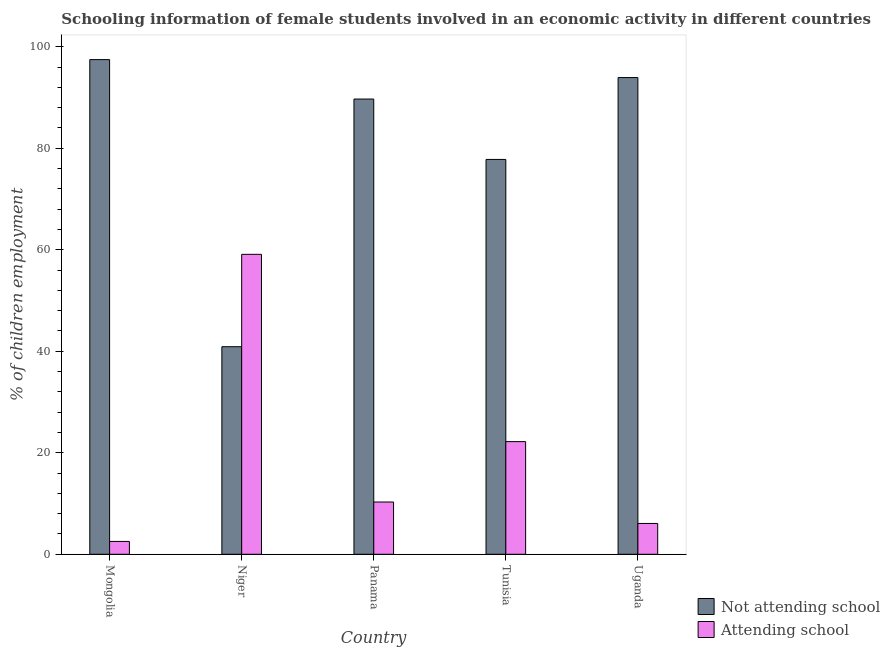How many different coloured bars are there?
Ensure brevity in your answer.  2. How many groups of bars are there?
Ensure brevity in your answer.  5. Are the number of bars per tick equal to the number of legend labels?
Give a very brief answer. Yes. Are the number of bars on each tick of the X-axis equal?
Provide a short and direct response. Yes. How many bars are there on the 5th tick from the right?
Your response must be concise. 2. What is the label of the 2nd group of bars from the left?
Offer a terse response. Niger. In how many cases, is the number of bars for a given country not equal to the number of legend labels?
Give a very brief answer. 0. What is the percentage of employed females who are not attending school in Niger?
Ensure brevity in your answer.  40.9. Across all countries, what is the maximum percentage of employed females who are attending school?
Your answer should be compact. 59.1. Across all countries, what is the minimum percentage of employed females who are attending school?
Keep it short and to the point. 2.53. In which country was the percentage of employed females who are not attending school maximum?
Your answer should be compact. Mongolia. In which country was the percentage of employed females who are not attending school minimum?
Provide a short and direct response. Niger. What is the total percentage of employed females who are attending school in the graph?
Offer a terse response. 100.2. What is the difference between the percentage of employed females who are attending school in Mongolia and that in Uganda?
Give a very brief answer. -3.54. What is the difference between the percentage of employed females who are not attending school in Panama and the percentage of employed females who are attending school in Mongolia?
Offer a terse response. 87.17. What is the average percentage of employed females who are attending school per country?
Your response must be concise. 20.04. What is the difference between the percentage of employed females who are attending school and percentage of employed females who are not attending school in Uganda?
Give a very brief answer. -87.86. In how many countries, is the percentage of employed females who are attending school greater than 56 %?
Provide a succinct answer. 1. What is the ratio of the percentage of employed females who are attending school in Mongolia to that in Panama?
Provide a succinct answer. 0.25. Is the percentage of employed females who are attending school in Mongolia less than that in Uganda?
Ensure brevity in your answer.  Yes. What is the difference between the highest and the second highest percentage of employed females who are not attending school?
Offer a very short reply. 3.54. What is the difference between the highest and the lowest percentage of employed females who are attending school?
Your answer should be compact. 56.57. What does the 2nd bar from the left in Mongolia represents?
Provide a succinct answer. Attending school. What does the 2nd bar from the right in Uganda represents?
Provide a succinct answer. Not attending school. How many bars are there?
Provide a succinct answer. 10. Are the values on the major ticks of Y-axis written in scientific E-notation?
Provide a short and direct response. No. How many legend labels are there?
Make the answer very short. 2. What is the title of the graph?
Keep it short and to the point. Schooling information of female students involved in an economic activity in different countries. Does "Primary completion rate" appear as one of the legend labels in the graph?
Provide a succinct answer. No. What is the label or title of the X-axis?
Offer a terse response. Country. What is the label or title of the Y-axis?
Provide a succinct answer. % of children employment. What is the % of children employment in Not attending school in Mongolia?
Provide a succinct answer. 97.47. What is the % of children employment in Attending school in Mongolia?
Make the answer very short. 2.53. What is the % of children employment in Not attending school in Niger?
Offer a terse response. 40.9. What is the % of children employment in Attending school in Niger?
Keep it short and to the point. 59.1. What is the % of children employment of Not attending school in Panama?
Give a very brief answer. 89.7. What is the % of children employment of Attending school in Panama?
Offer a terse response. 10.3. What is the % of children employment in Not attending school in Tunisia?
Your answer should be very brief. 77.8. What is the % of children employment in Not attending school in Uganda?
Make the answer very short. 93.93. What is the % of children employment of Attending school in Uganda?
Offer a terse response. 6.07. Across all countries, what is the maximum % of children employment in Not attending school?
Ensure brevity in your answer.  97.47. Across all countries, what is the maximum % of children employment of Attending school?
Provide a short and direct response. 59.1. Across all countries, what is the minimum % of children employment of Not attending school?
Offer a terse response. 40.9. Across all countries, what is the minimum % of children employment of Attending school?
Your answer should be very brief. 2.53. What is the total % of children employment in Not attending school in the graph?
Your response must be concise. 399.8. What is the total % of children employment in Attending school in the graph?
Ensure brevity in your answer.  100.2. What is the difference between the % of children employment of Not attending school in Mongolia and that in Niger?
Provide a succinct answer. 56.57. What is the difference between the % of children employment in Attending school in Mongolia and that in Niger?
Your response must be concise. -56.57. What is the difference between the % of children employment of Not attending school in Mongolia and that in Panama?
Ensure brevity in your answer.  7.77. What is the difference between the % of children employment in Attending school in Mongolia and that in Panama?
Your answer should be very brief. -7.77. What is the difference between the % of children employment in Not attending school in Mongolia and that in Tunisia?
Your answer should be very brief. 19.67. What is the difference between the % of children employment of Attending school in Mongolia and that in Tunisia?
Keep it short and to the point. -19.67. What is the difference between the % of children employment in Not attending school in Mongolia and that in Uganda?
Your answer should be very brief. 3.54. What is the difference between the % of children employment of Attending school in Mongolia and that in Uganda?
Provide a short and direct response. -3.54. What is the difference between the % of children employment in Not attending school in Niger and that in Panama?
Offer a very short reply. -48.8. What is the difference between the % of children employment of Attending school in Niger and that in Panama?
Keep it short and to the point. 48.8. What is the difference between the % of children employment in Not attending school in Niger and that in Tunisia?
Keep it short and to the point. -36.9. What is the difference between the % of children employment in Attending school in Niger and that in Tunisia?
Your answer should be very brief. 36.9. What is the difference between the % of children employment in Not attending school in Niger and that in Uganda?
Your response must be concise. -53.03. What is the difference between the % of children employment in Attending school in Niger and that in Uganda?
Your response must be concise. 53.03. What is the difference between the % of children employment of Not attending school in Panama and that in Tunisia?
Keep it short and to the point. 11.9. What is the difference between the % of children employment of Not attending school in Panama and that in Uganda?
Offer a very short reply. -4.23. What is the difference between the % of children employment in Attending school in Panama and that in Uganda?
Your answer should be compact. 4.23. What is the difference between the % of children employment of Not attending school in Tunisia and that in Uganda?
Keep it short and to the point. -16.13. What is the difference between the % of children employment of Attending school in Tunisia and that in Uganda?
Make the answer very short. 16.13. What is the difference between the % of children employment in Not attending school in Mongolia and the % of children employment in Attending school in Niger?
Make the answer very short. 38.37. What is the difference between the % of children employment of Not attending school in Mongolia and the % of children employment of Attending school in Panama?
Offer a terse response. 87.17. What is the difference between the % of children employment of Not attending school in Mongolia and the % of children employment of Attending school in Tunisia?
Offer a terse response. 75.27. What is the difference between the % of children employment of Not attending school in Mongolia and the % of children employment of Attending school in Uganda?
Provide a succinct answer. 91.4. What is the difference between the % of children employment in Not attending school in Niger and the % of children employment in Attending school in Panama?
Ensure brevity in your answer.  30.6. What is the difference between the % of children employment in Not attending school in Niger and the % of children employment in Attending school in Tunisia?
Ensure brevity in your answer.  18.7. What is the difference between the % of children employment in Not attending school in Niger and the % of children employment in Attending school in Uganda?
Your response must be concise. 34.83. What is the difference between the % of children employment in Not attending school in Panama and the % of children employment in Attending school in Tunisia?
Make the answer very short. 67.5. What is the difference between the % of children employment of Not attending school in Panama and the % of children employment of Attending school in Uganda?
Make the answer very short. 83.63. What is the difference between the % of children employment of Not attending school in Tunisia and the % of children employment of Attending school in Uganda?
Make the answer very short. 71.73. What is the average % of children employment in Not attending school per country?
Keep it short and to the point. 79.96. What is the average % of children employment of Attending school per country?
Provide a succinct answer. 20.04. What is the difference between the % of children employment of Not attending school and % of children employment of Attending school in Mongolia?
Provide a succinct answer. 94.94. What is the difference between the % of children employment in Not attending school and % of children employment in Attending school in Niger?
Give a very brief answer. -18.2. What is the difference between the % of children employment of Not attending school and % of children employment of Attending school in Panama?
Your response must be concise. 79.4. What is the difference between the % of children employment of Not attending school and % of children employment of Attending school in Tunisia?
Provide a succinct answer. 55.6. What is the difference between the % of children employment in Not attending school and % of children employment in Attending school in Uganda?
Your answer should be compact. 87.86. What is the ratio of the % of children employment of Not attending school in Mongolia to that in Niger?
Give a very brief answer. 2.38. What is the ratio of the % of children employment of Attending school in Mongolia to that in Niger?
Make the answer very short. 0.04. What is the ratio of the % of children employment of Not attending school in Mongolia to that in Panama?
Keep it short and to the point. 1.09. What is the ratio of the % of children employment of Attending school in Mongolia to that in Panama?
Keep it short and to the point. 0.25. What is the ratio of the % of children employment in Not attending school in Mongolia to that in Tunisia?
Provide a short and direct response. 1.25. What is the ratio of the % of children employment of Attending school in Mongolia to that in Tunisia?
Keep it short and to the point. 0.11. What is the ratio of the % of children employment of Not attending school in Mongolia to that in Uganda?
Your response must be concise. 1.04. What is the ratio of the % of children employment in Attending school in Mongolia to that in Uganda?
Your answer should be compact. 0.42. What is the ratio of the % of children employment of Not attending school in Niger to that in Panama?
Your answer should be very brief. 0.46. What is the ratio of the % of children employment of Attending school in Niger to that in Panama?
Provide a succinct answer. 5.74. What is the ratio of the % of children employment of Not attending school in Niger to that in Tunisia?
Your answer should be compact. 0.53. What is the ratio of the % of children employment of Attending school in Niger to that in Tunisia?
Keep it short and to the point. 2.66. What is the ratio of the % of children employment in Not attending school in Niger to that in Uganda?
Keep it short and to the point. 0.44. What is the ratio of the % of children employment of Attending school in Niger to that in Uganda?
Provide a succinct answer. 9.73. What is the ratio of the % of children employment of Not attending school in Panama to that in Tunisia?
Keep it short and to the point. 1.15. What is the ratio of the % of children employment in Attending school in Panama to that in Tunisia?
Your answer should be compact. 0.46. What is the ratio of the % of children employment of Not attending school in Panama to that in Uganda?
Keep it short and to the point. 0.95. What is the ratio of the % of children employment in Attending school in Panama to that in Uganda?
Provide a short and direct response. 1.7. What is the ratio of the % of children employment of Not attending school in Tunisia to that in Uganda?
Offer a very short reply. 0.83. What is the ratio of the % of children employment of Attending school in Tunisia to that in Uganda?
Offer a very short reply. 3.66. What is the difference between the highest and the second highest % of children employment of Not attending school?
Offer a very short reply. 3.54. What is the difference between the highest and the second highest % of children employment in Attending school?
Provide a short and direct response. 36.9. What is the difference between the highest and the lowest % of children employment in Not attending school?
Provide a succinct answer. 56.57. What is the difference between the highest and the lowest % of children employment of Attending school?
Ensure brevity in your answer.  56.57. 